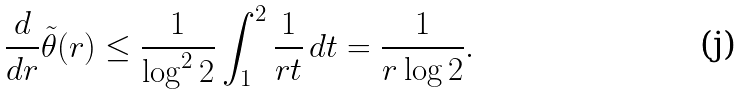Convert formula to latex. <formula><loc_0><loc_0><loc_500><loc_500>\frac { d } { d r } \tilde { \theta } ( r ) \leq \frac { 1 } { \log ^ { 2 } 2 } \int _ { 1 } ^ { 2 } \frac { 1 } { r t } \, d t = \frac { 1 } { r \log 2 } .</formula> 